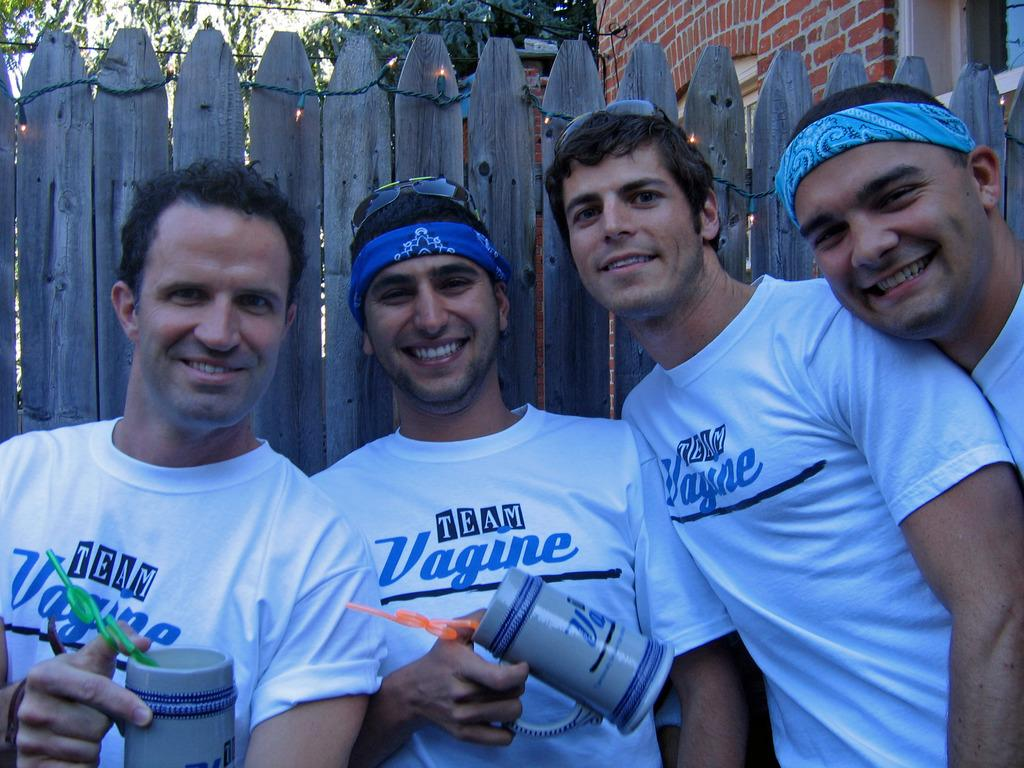<image>
Present a compact description of the photo's key features. A few men in Team Vagine shirts stand in front of a wooden fence. 